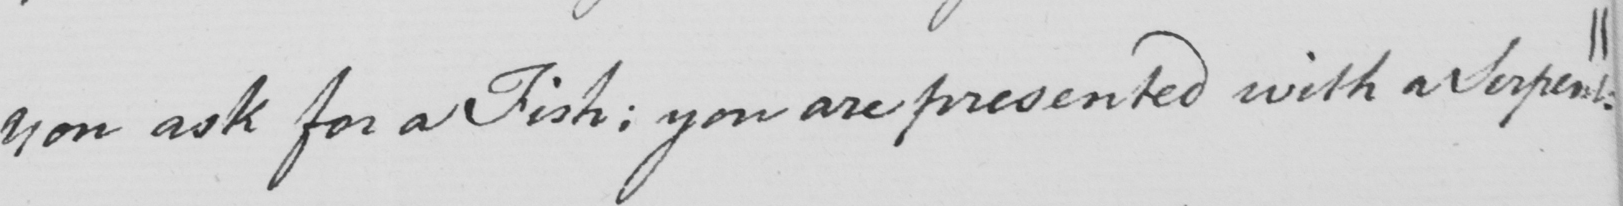Can you tell me what this handwritten text says? you ask for a Fish ; you are presented with a Serpent . || 